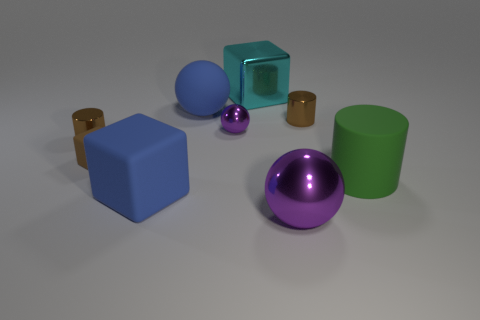Add 1 big yellow cylinders. How many objects exist? 10 Subtract all big purple objects. Subtract all small brown matte blocks. How many objects are left? 7 Add 4 blue cubes. How many blue cubes are left? 5 Add 3 yellow balls. How many yellow balls exist? 3 Subtract 0 cyan cylinders. How many objects are left? 9 Subtract all spheres. How many objects are left? 6 